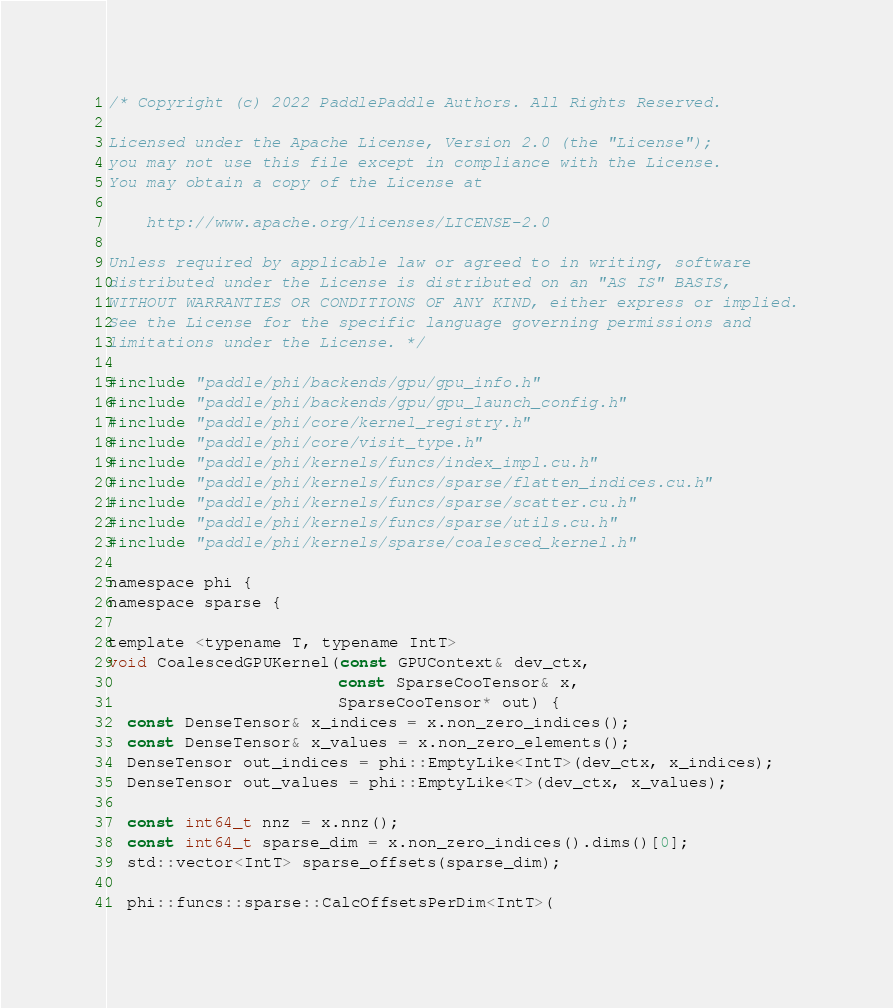<code> <loc_0><loc_0><loc_500><loc_500><_Cuda_>/* Copyright (c) 2022 PaddlePaddle Authors. All Rights Reserved.

Licensed under the Apache License, Version 2.0 (the "License");
you may not use this file except in compliance with the License.
You may obtain a copy of the License at

    http://www.apache.org/licenses/LICENSE-2.0

Unless required by applicable law or agreed to in writing, software
distributed under the License is distributed on an "AS IS" BASIS,
WITHOUT WARRANTIES OR CONDITIONS OF ANY KIND, either express or implied.
See the License for the specific language governing permissions and
limitations under the License. */

#include "paddle/phi/backends/gpu/gpu_info.h"
#include "paddle/phi/backends/gpu/gpu_launch_config.h"
#include "paddle/phi/core/kernel_registry.h"
#include "paddle/phi/core/visit_type.h"
#include "paddle/phi/kernels/funcs/index_impl.cu.h"
#include "paddle/phi/kernels/funcs/sparse/flatten_indices.cu.h"
#include "paddle/phi/kernels/funcs/sparse/scatter.cu.h"
#include "paddle/phi/kernels/funcs/sparse/utils.cu.h"
#include "paddle/phi/kernels/sparse/coalesced_kernel.h"

namespace phi {
namespace sparse {

template <typename T, typename IntT>
void CoalescedGPUKernel(const GPUContext& dev_ctx,
                        const SparseCooTensor& x,
                        SparseCooTensor* out) {
  const DenseTensor& x_indices = x.non_zero_indices();
  const DenseTensor& x_values = x.non_zero_elements();
  DenseTensor out_indices = phi::EmptyLike<IntT>(dev_ctx, x_indices);
  DenseTensor out_values = phi::EmptyLike<T>(dev_ctx, x_values);

  const int64_t nnz = x.nnz();
  const int64_t sparse_dim = x.non_zero_indices().dims()[0];
  std::vector<IntT> sparse_offsets(sparse_dim);

  phi::funcs::sparse::CalcOffsetsPerDim<IntT>(</code> 